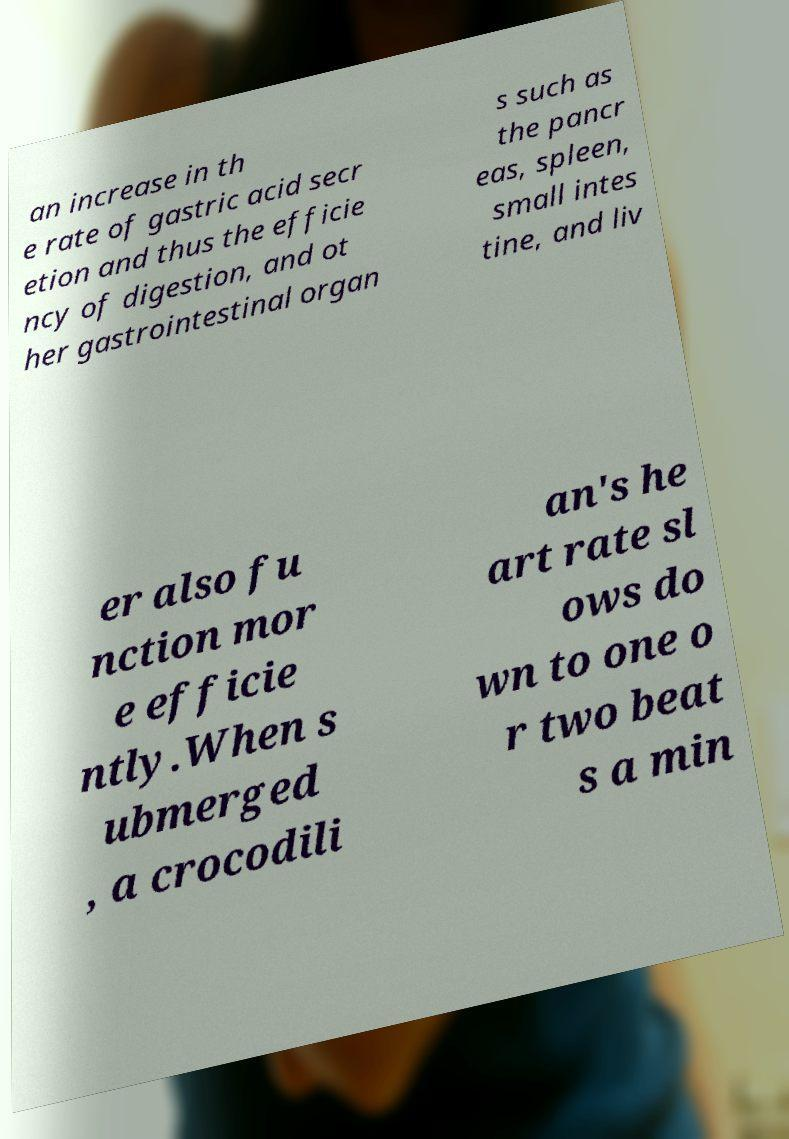There's text embedded in this image that I need extracted. Can you transcribe it verbatim? an increase in th e rate of gastric acid secr etion and thus the efficie ncy of digestion, and ot her gastrointestinal organ s such as the pancr eas, spleen, small intes tine, and liv er also fu nction mor e efficie ntly.When s ubmerged , a crocodili an's he art rate sl ows do wn to one o r two beat s a min 